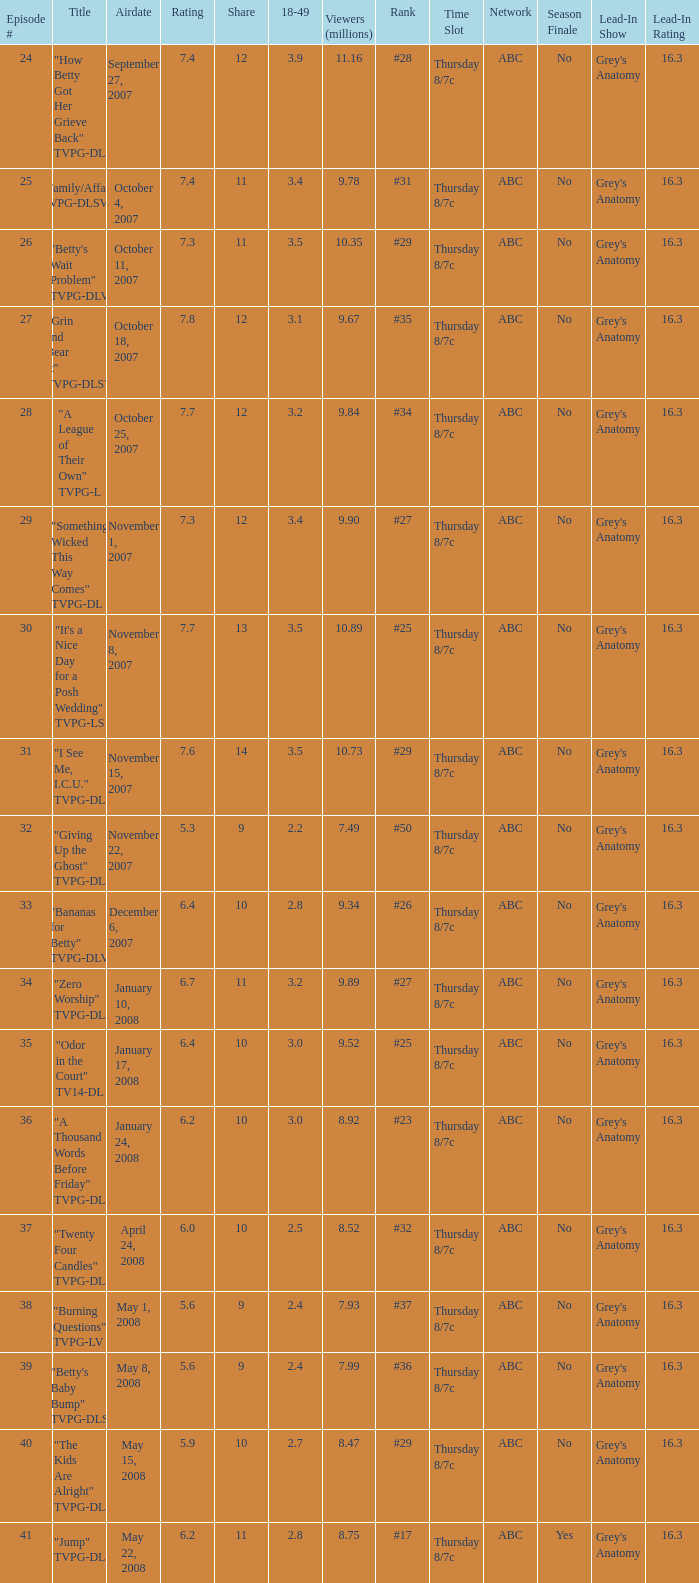What is the Airdate of the episode that ranked #29 and had a share greater than 10? May 15, 2008. 